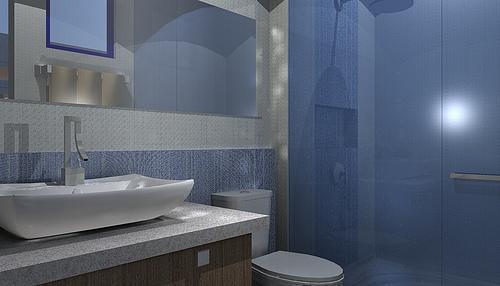How many toilets in the picture?
Give a very brief answer. 1. 